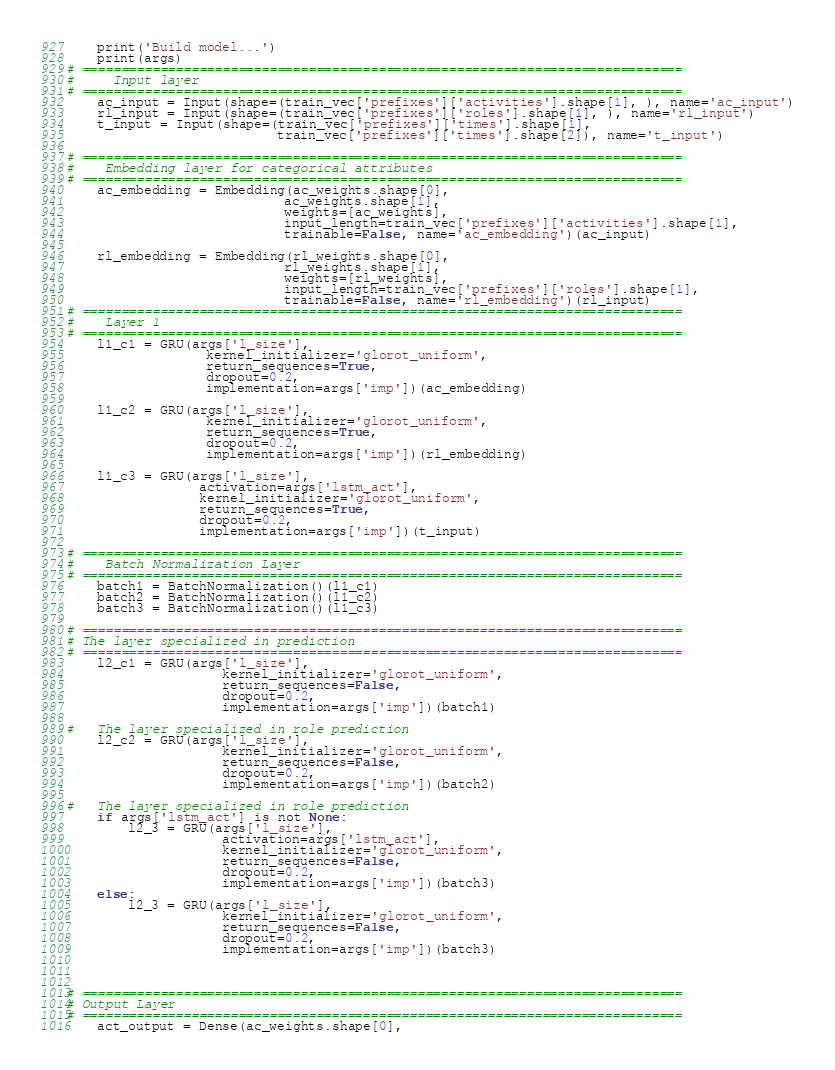Convert code to text. <code><loc_0><loc_0><loc_500><loc_500><_Python_>    print('Build model...')
    print(args)
# =============================================================================
#     Input layer
# =============================================================================
    ac_input = Input(shape=(train_vec['prefixes']['activities'].shape[1], ), name='ac_input')
    rl_input = Input(shape=(train_vec['prefixes']['roles'].shape[1], ), name='rl_input')
    t_input = Input(shape=(train_vec['prefixes']['times'].shape[1],
                           train_vec['prefixes']['times'].shape[2]), name='t_input')

# =============================================================================
#    Embedding layer for categorical attributes        
# =============================================================================
    ac_embedding = Embedding(ac_weights.shape[0],
                            ac_weights.shape[1],
                            weights=[ac_weights],
                            input_length=train_vec['prefixes']['activities'].shape[1],
                            trainable=False, name='ac_embedding')(ac_input)

    rl_embedding = Embedding(rl_weights.shape[0],
                            rl_weights.shape[1],
                            weights=[rl_weights],
                            input_length=train_vec['prefixes']['roles'].shape[1],
                            trainable=False, name='rl_embedding')(rl_input)
# =============================================================================
#    Layer 1
# =============================================================================
    l1_c1 = GRU(args['l_size'],
                  kernel_initializer='glorot_uniform',
                  return_sequences=True,
                  dropout=0.2,
                  implementation=args['imp'])(ac_embedding)
    
    l1_c2 = GRU(args['l_size'],
                  kernel_initializer='glorot_uniform',
                  return_sequences=True,
                  dropout=0.2,
                  implementation=args['imp'])(rl_embedding)

    l1_c3 = GRU(args['l_size'],
                 activation=args['lstm_act'],
                 kernel_initializer='glorot_uniform',
                 return_sequences=True,
                 dropout=0.2,
                 implementation=args['imp'])(t_input)

# =============================================================================
#    Batch Normalization Layer
# =============================================================================
    batch1 = BatchNormalization()(l1_c1)
    batch2 = BatchNormalization()(l1_c2)
    batch3 = BatchNormalization()(l1_c3)
    
# =============================================================================
# The layer specialized in prediction
# =============================================================================
    l2_c1 = GRU(args['l_size'],
                    kernel_initializer='glorot_uniform',
                    return_sequences=False,
                    dropout=0.2,
                    implementation=args['imp'])(batch1)
 
#   The layer specialized in role prediction
    l2_c2 = GRU(args['l_size'],
                    kernel_initializer='glorot_uniform',
                    return_sequences=False,
                    dropout=0.2,
                    implementation=args['imp'])(batch2)
    
#   The layer specialized in role prediction
    if args['lstm_act'] is not None:
        l2_3 = GRU(args['l_size'],
                    activation=args['lstm_act'],
                    kernel_initializer='glorot_uniform',
                    return_sequences=False,
                    dropout=0.2,
                    implementation=args['imp'])(batch3)
    else:
        l2_3 = GRU(args['l_size'],
                    kernel_initializer='glorot_uniform',
                    return_sequences=False,
                    dropout=0.2,
                    implementation=args['imp'])(batch3)
    

    
# =============================================================================
# Output Layer
# =============================================================================
    act_output = Dense(ac_weights.shape[0],</code> 